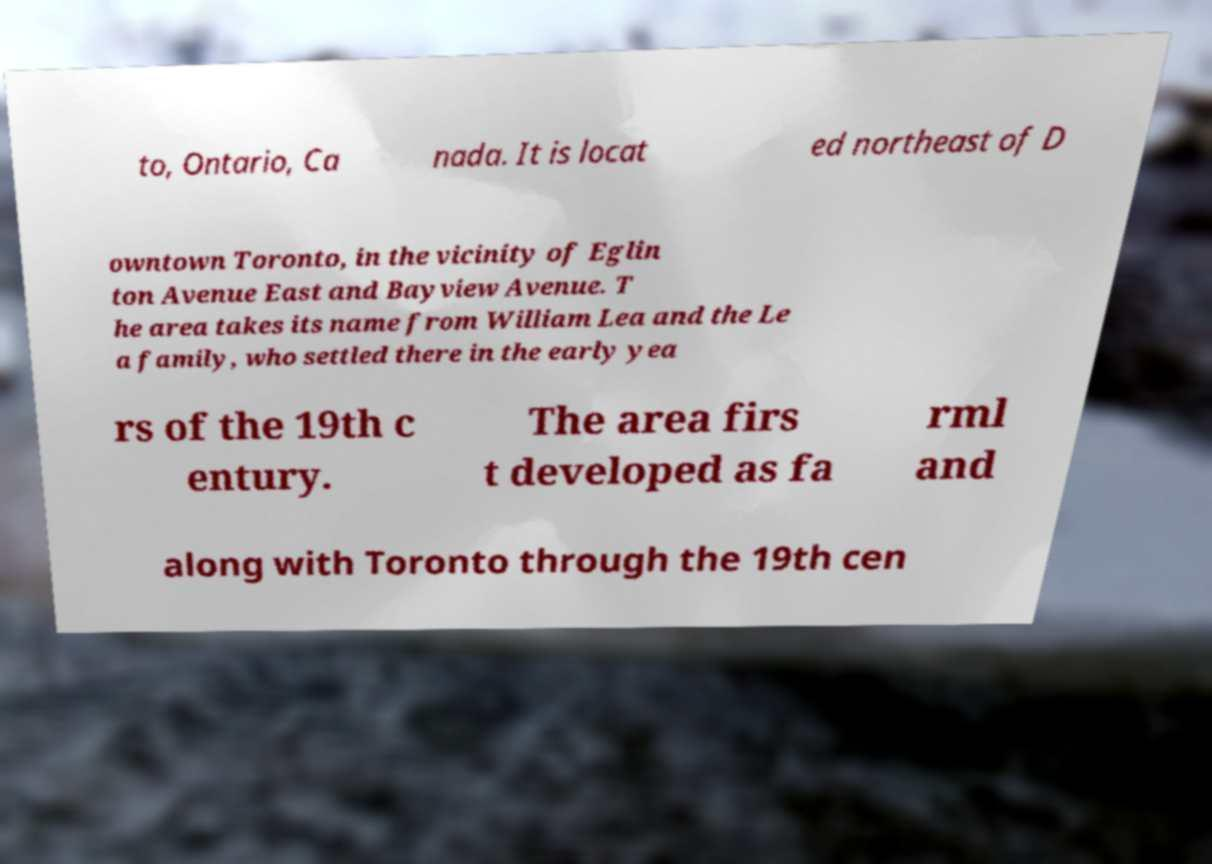What messages or text are displayed in this image? I need them in a readable, typed format. to, Ontario, Ca nada. It is locat ed northeast of D owntown Toronto, in the vicinity of Eglin ton Avenue East and Bayview Avenue. T he area takes its name from William Lea and the Le a family, who settled there in the early yea rs of the 19th c entury. The area firs t developed as fa rml and along with Toronto through the 19th cen 